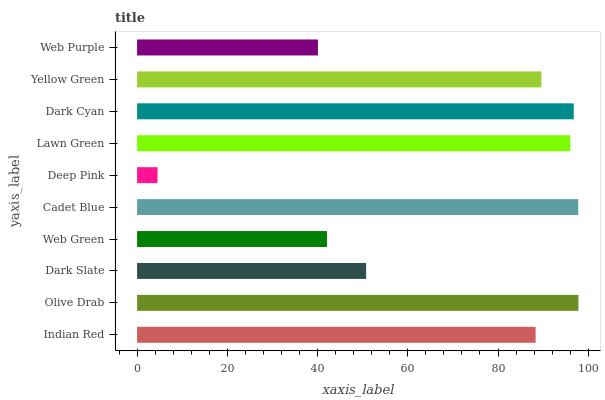Is Deep Pink the minimum?
Answer yes or no. Yes. Is Olive Drab the maximum?
Answer yes or no. Yes. Is Dark Slate the minimum?
Answer yes or no. No. Is Dark Slate the maximum?
Answer yes or no. No. Is Olive Drab greater than Dark Slate?
Answer yes or no. Yes. Is Dark Slate less than Olive Drab?
Answer yes or no. Yes. Is Dark Slate greater than Olive Drab?
Answer yes or no. No. Is Olive Drab less than Dark Slate?
Answer yes or no. No. Is Yellow Green the high median?
Answer yes or no. Yes. Is Indian Red the low median?
Answer yes or no. Yes. Is Web Purple the high median?
Answer yes or no. No. Is Dark Cyan the low median?
Answer yes or no. No. 